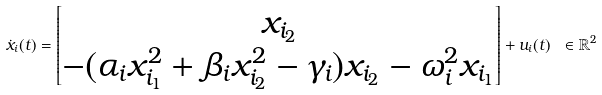<formula> <loc_0><loc_0><loc_500><loc_500>\dot { x } _ { i } ( t ) = \begin{bmatrix} x _ { i _ { 2 } } \\ - ( \alpha _ { i } x _ { i _ { 1 } } ^ { 2 } + \beta _ { i } x _ { i _ { 2 } } ^ { 2 } - \gamma _ { i } ) x _ { i _ { 2 } } - \omega _ { i } ^ { 2 } x _ { i _ { 1 } } \end{bmatrix} + u _ { i } ( t ) \ \in \mathbb { R } ^ { 2 }</formula> 